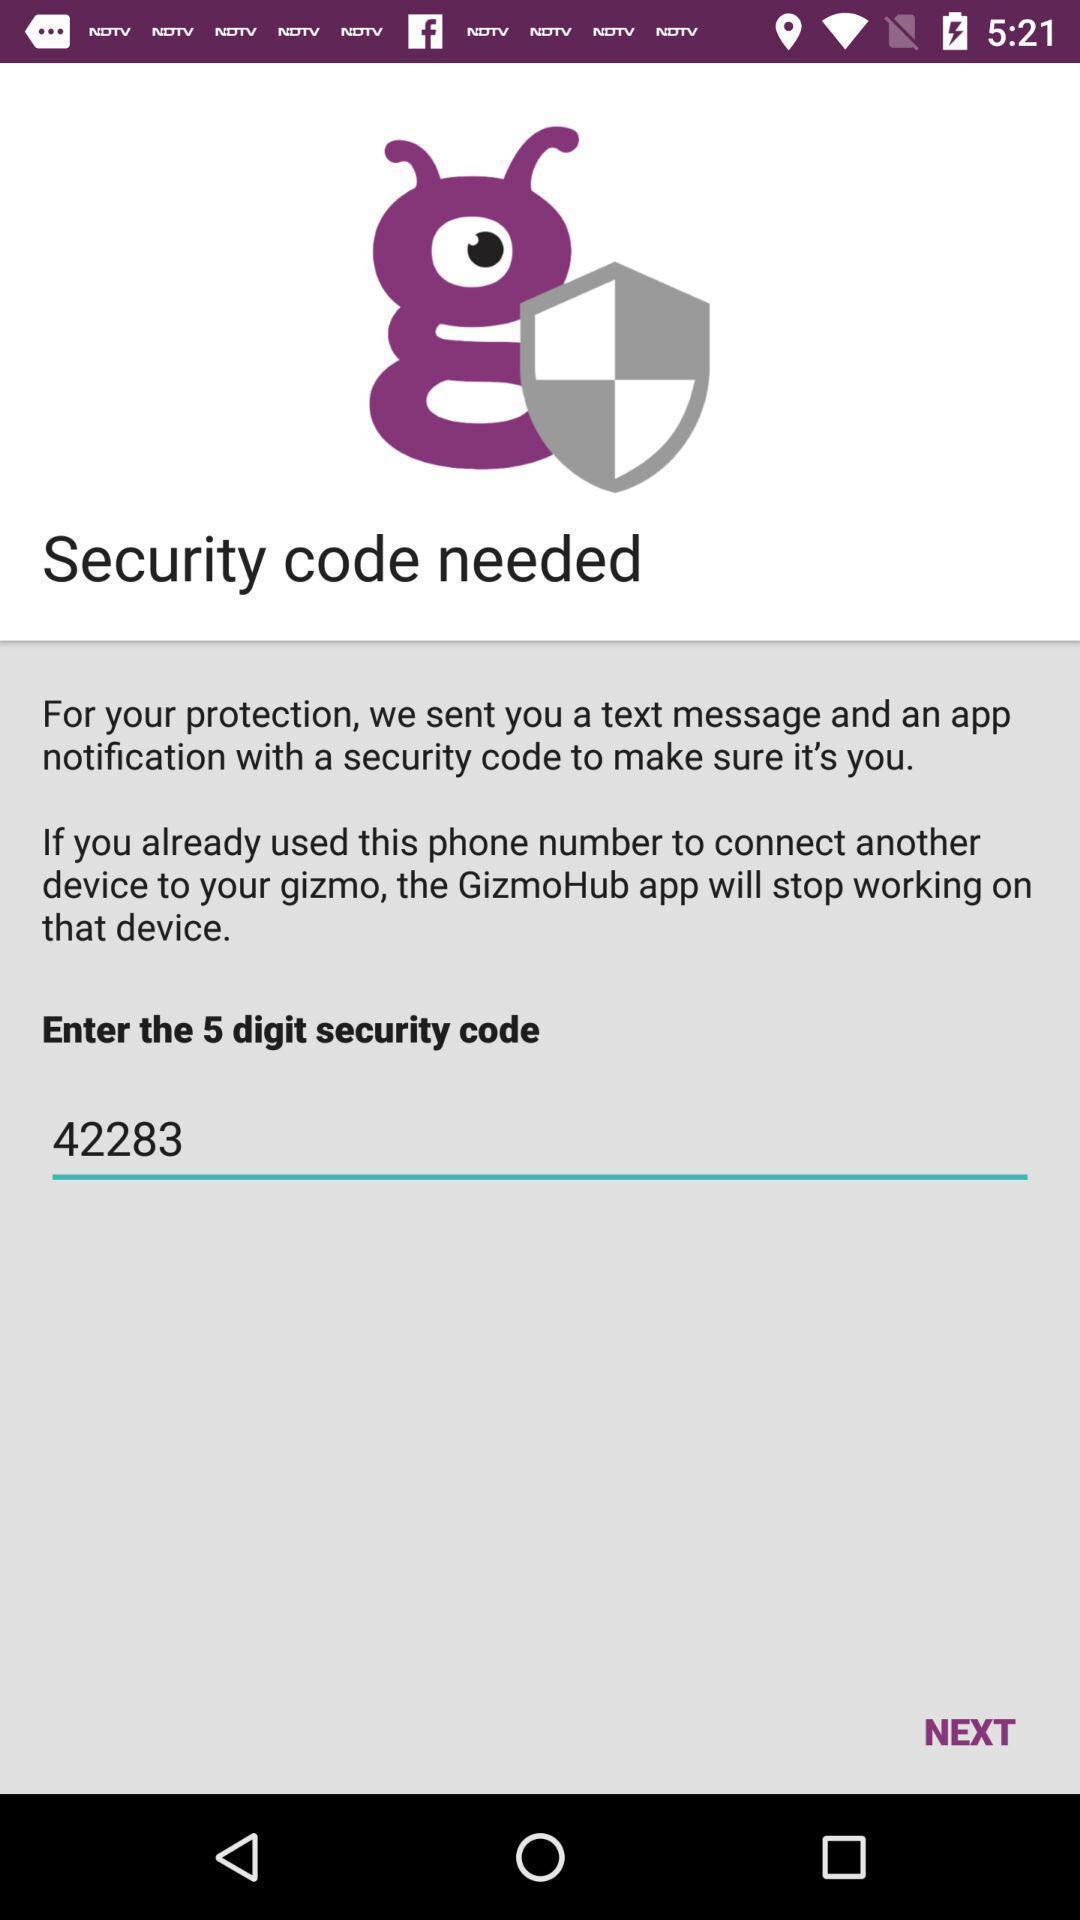Summarize the main components in this picture. Page showing about security options. 